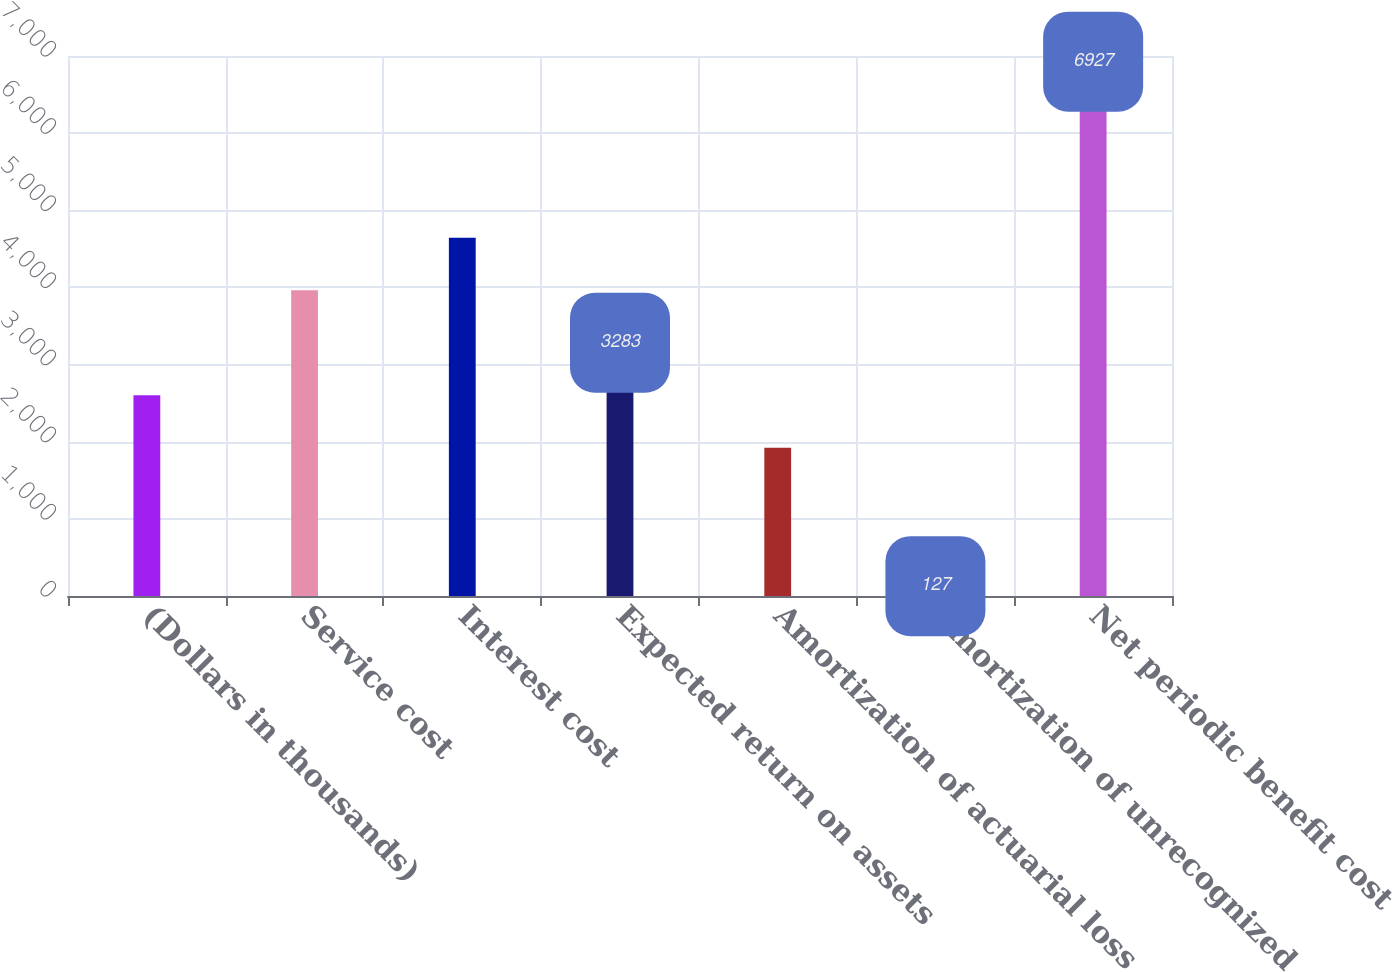Convert chart. <chart><loc_0><loc_0><loc_500><loc_500><bar_chart><fcel>(Dollars in thousands)<fcel>Service cost<fcel>Interest cost<fcel>Expected return on assets<fcel>Amortization of actuarial loss<fcel>Amortization of unrecognized<fcel>Net periodic benefit cost<nl><fcel>2603<fcel>3963<fcel>4643<fcel>3283<fcel>1923<fcel>127<fcel>6927<nl></chart> 